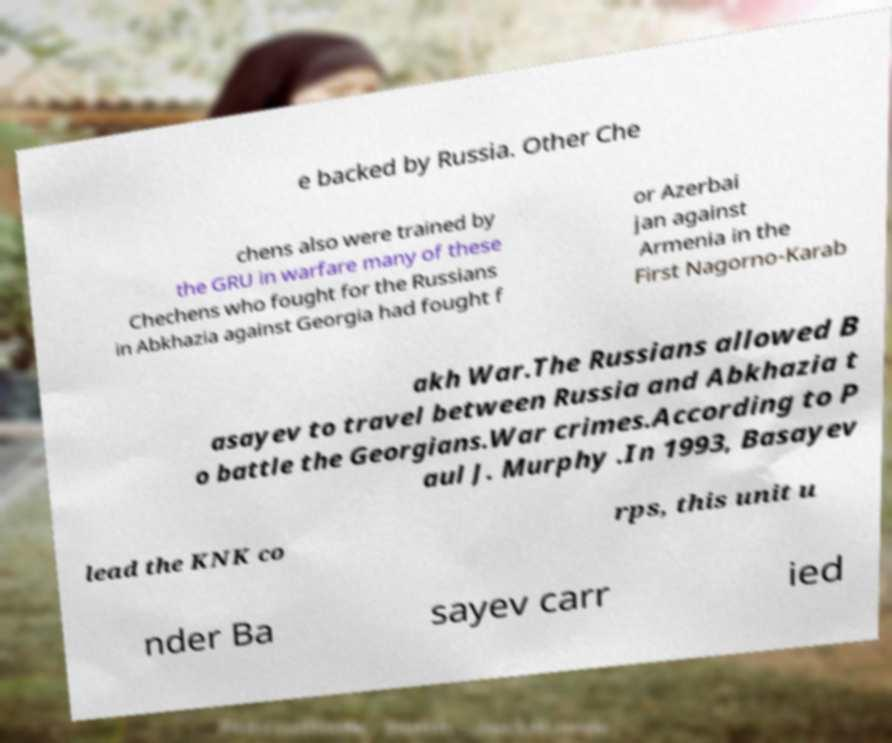What messages or text are displayed in this image? I need them in a readable, typed format. e backed by Russia. Other Che chens also were trained by the GRU in warfare many of these Chechens who fought for the Russians in Abkhazia against Georgia had fought f or Azerbai jan against Armenia in the First Nagorno-Karab akh War.The Russians allowed B asayev to travel between Russia and Abkhazia t o battle the Georgians.War crimes.According to P aul J. Murphy .In 1993, Basayev lead the KNK co rps, this unit u nder Ba sayev carr ied 